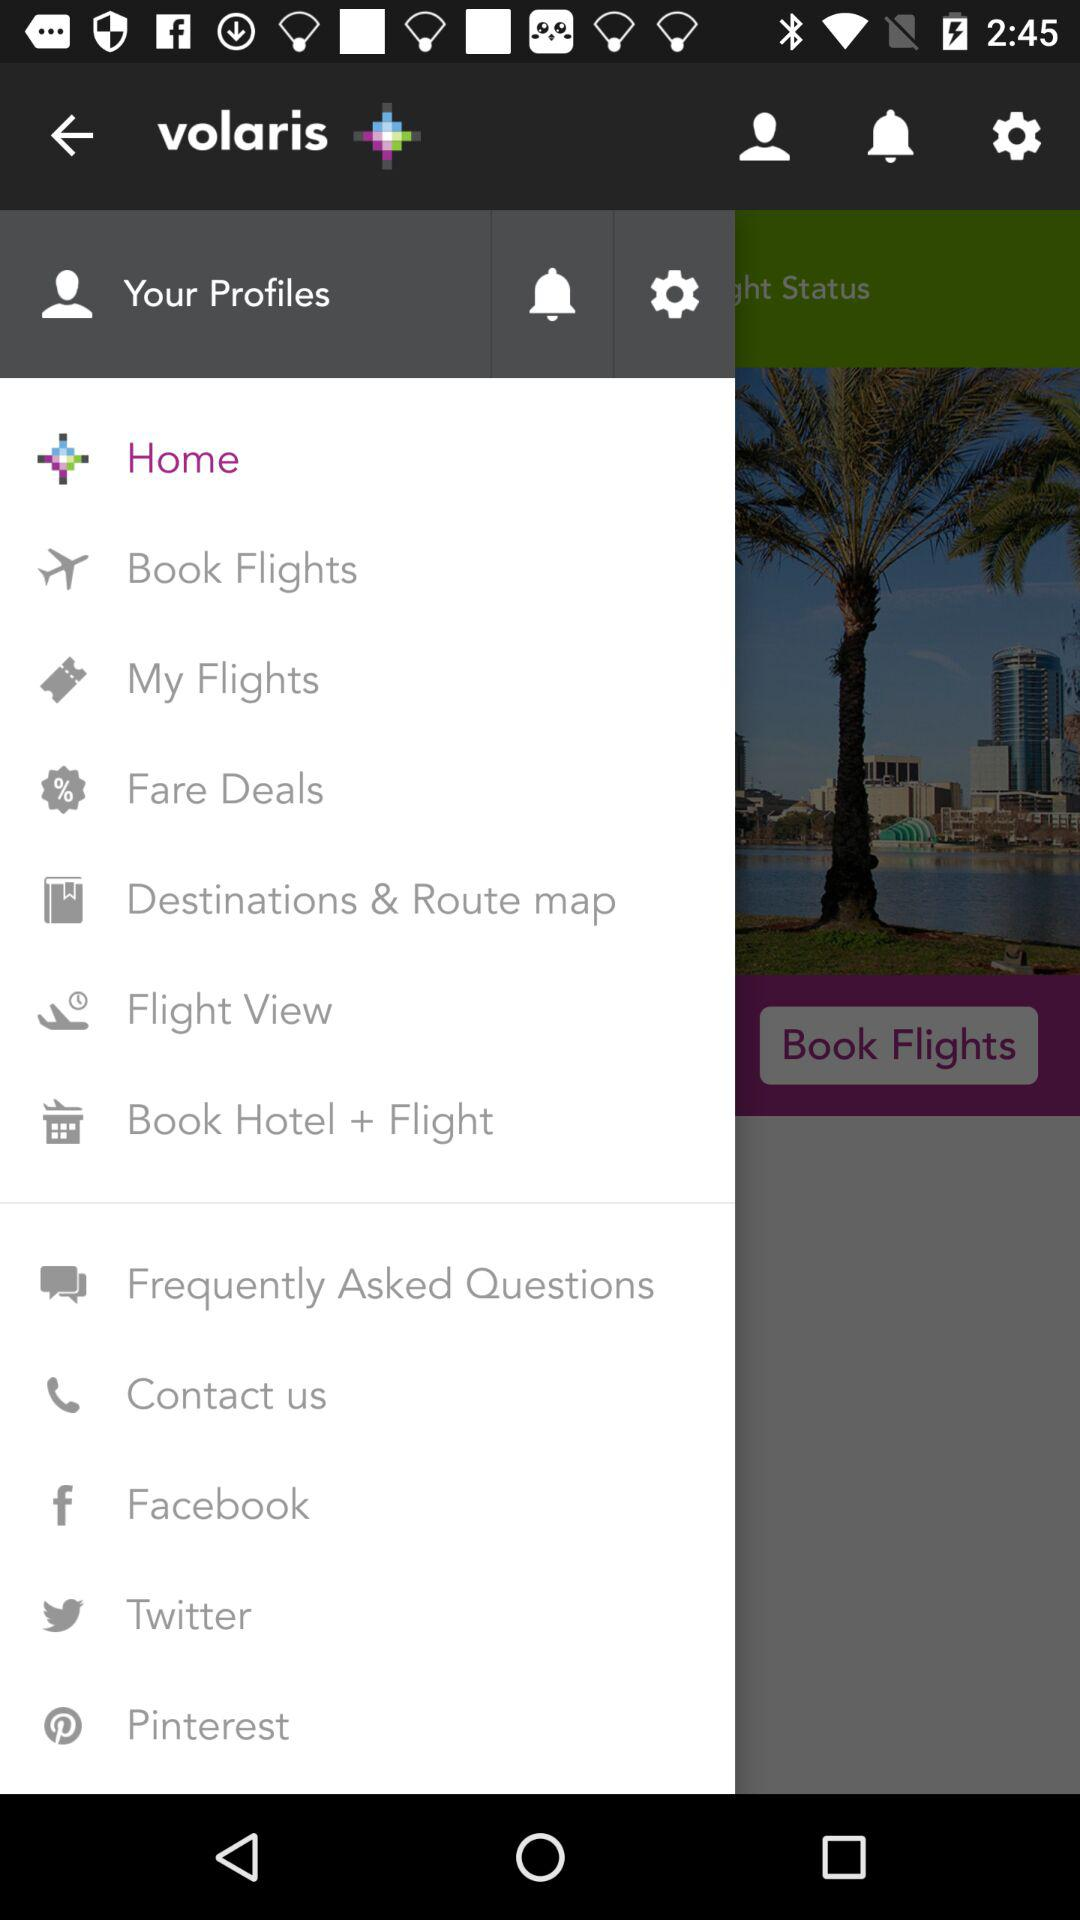What is the name of the application? The name of the application is "volaris". 